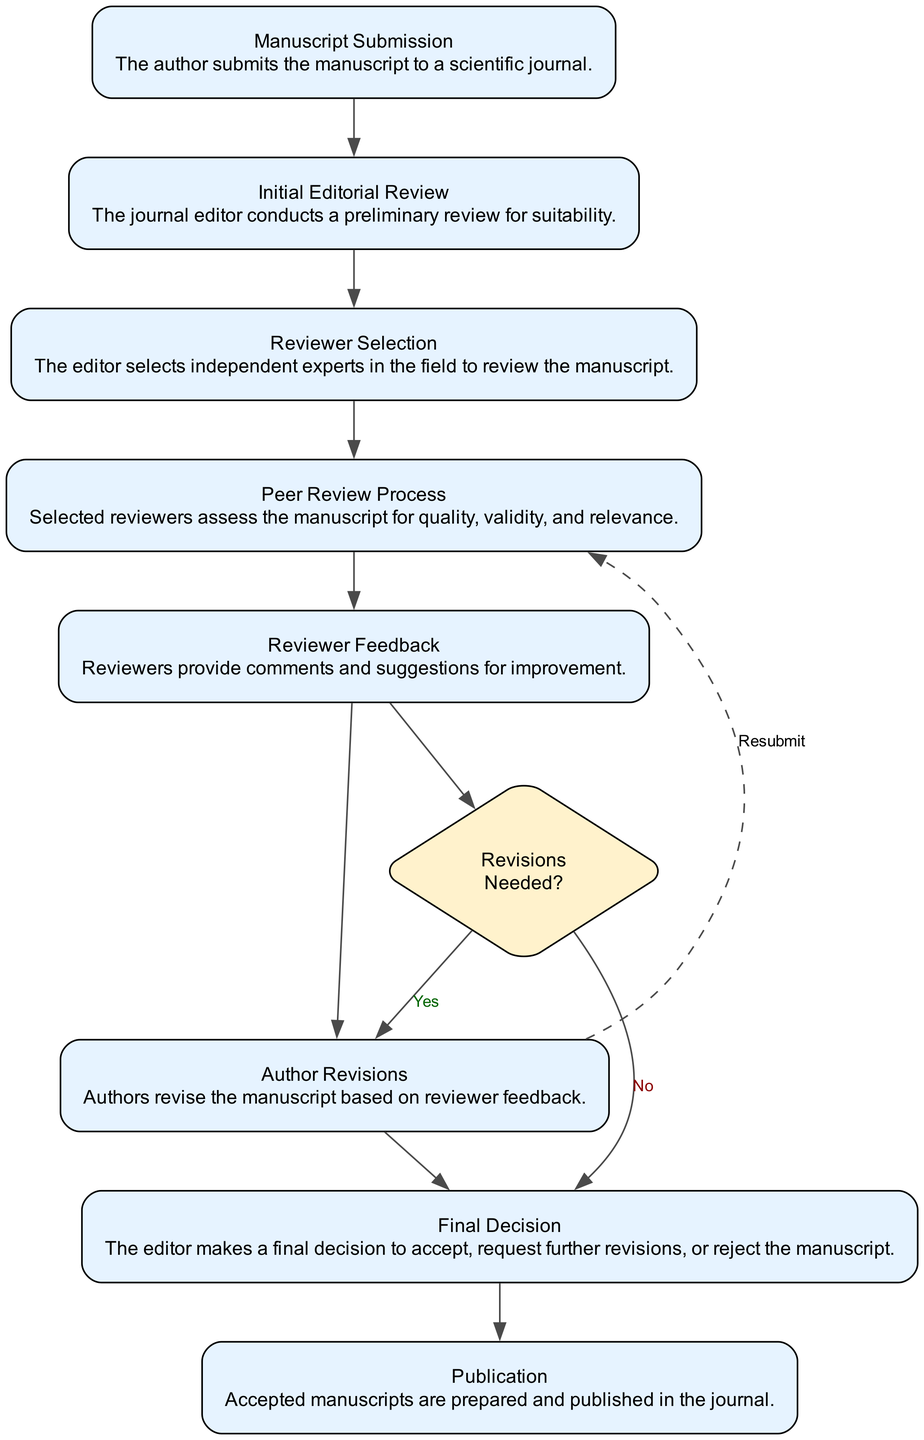What is the first step in the peer review process? The first step listed in the diagram is "Manuscript Submission," where the author submits the manuscript to a scientific journal.
Answer: Manuscript Submission How many nodes are in the diagram? The diagram contains a total of 8 nodes representing different stages of the peer review process, from manuscript submission to publication.
Answer: 8 What stage comes after "Reviewer Feedback"? The stage that comes after "Reviewer Feedback" is the "Final Decision," which follows the feedback from the reviewers.
Answer: Final Decision What is the role of the "Reviewer Selection" node? The "Reviewer Selection" node indicates that the editor chooses independent experts in the field to review the manuscript, which is a crucial step in ensuring the manuscript is evaluated by qualified individuals.
Answer: Editor selects independent experts When are revisions needed in the peer review process? Revisions are needed when the decision node indicates "Revisions Needed?" and the answer is "Yes," leading the authors to revise their manuscript based on feedback.
Answer: When the answer is Yes Which stage leads directly to publication if the manuscript is accepted? If the manuscript is accepted, it goes directly to the "Publication" stage, where accepted manuscripts are prepared and published in the journal.
Answer: Publication What happens if the reviewers suggest changes? If the reviewers suggest changes, the feedback leads to the "Author Revisions" stage, where authors revise the manuscript based on the reviewers' comments and suggestions.
Answer: Author Revisions What is the purpose of the "Initial Editorial Review"? The purpose of the "Initial Editorial Review" is for the journal editor to conduct a preliminary review for the suitability of the submitted manuscript before it undergoes peer review.
Answer: Preliminary review for suitability What indicates that the manuscript might need to go back into the review process? If the decision at the "Final Decision" stage indicates that revisions are necessary, the manuscript will be directed back into the review process, indicated by the "Resubmit" dashed line from "Author Revisions."
Answer: Resubmit 